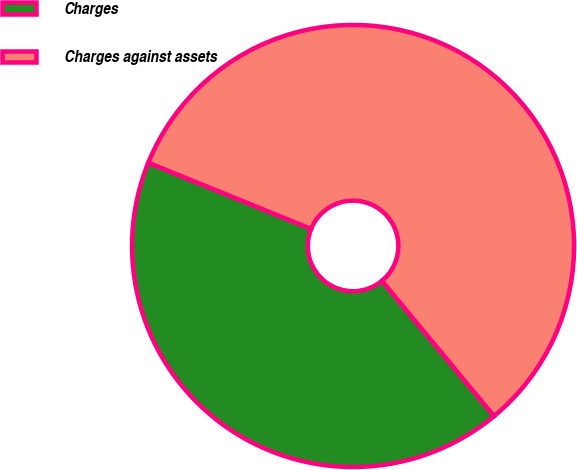<chart> <loc_0><loc_0><loc_500><loc_500><pie_chart><fcel>Charges<fcel>Charges against assets<nl><fcel>42.15%<fcel>57.85%<nl></chart> 